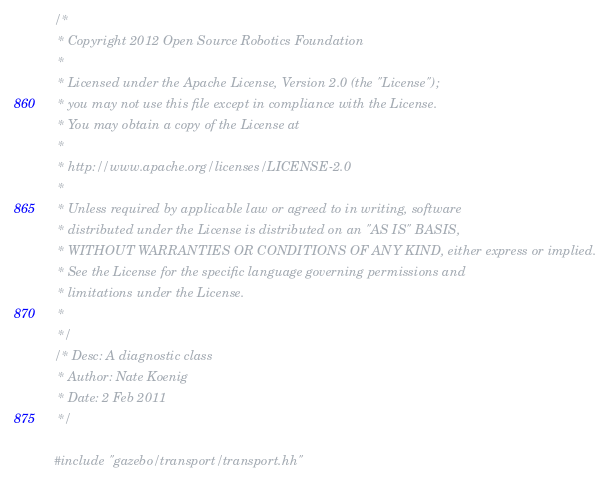Convert code to text. <code><loc_0><loc_0><loc_500><loc_500><_C++_>/*
 * Copyright 2012 Open Source Robotics Foundation
 *
 * Licensed under the Apache License, Version 2.0 (the "License");
 * you may not use this file except in compliance with the License.
 * You may obtain a copy of the License at
 *
 * http://www.apache.org/licenses/LICENSE-2.0
 *
 * Unless required by applicable law or agreed to in writing, software
 * distributed under the License is distributed on an "AS IS" BASIS,
 * WITHOUT WARRANTIES OR CONDITIONS OF ANY KIND, either express or implied.
 * See the License for the specific language governing permissions and
 * limitations under the License.
 *
 */
/* Desc: A diagnostic class
 * Author: Nate Koenig
 * Date: 2 Feb 2011
 */

#include "gazebo/transport/transport.hh"</code> 